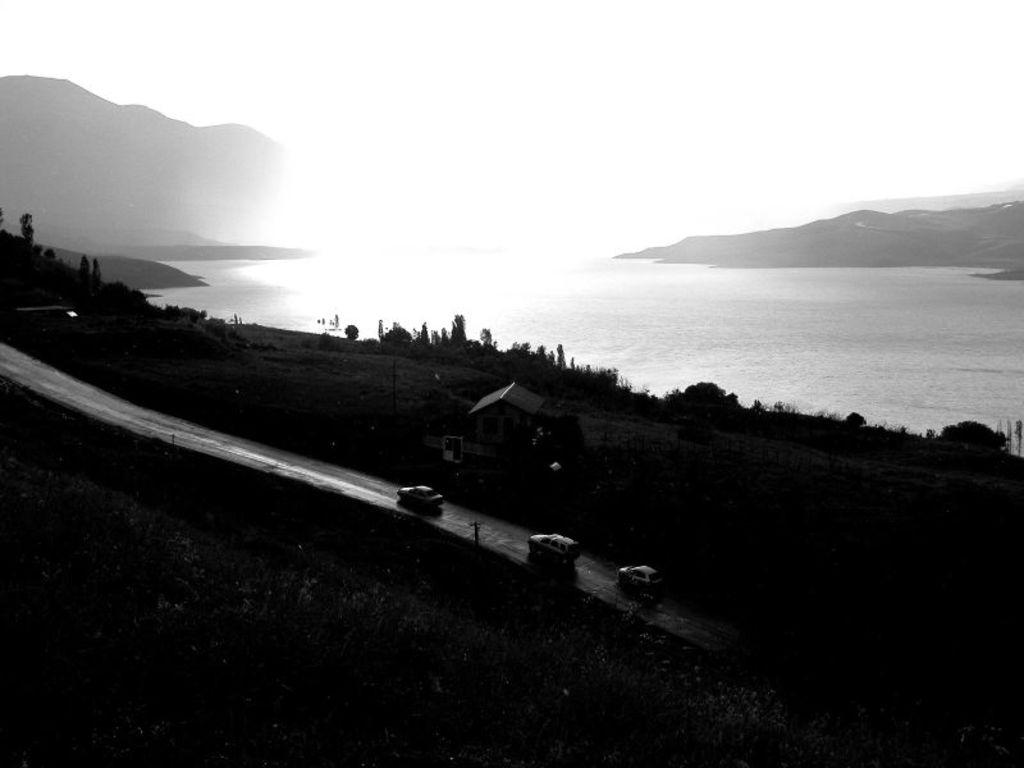What can be seen in the image? There are cars in the image. What type of vegetation or plants are visible at the bottom side of the image? There is greenery at the bottom side of the image. What natural feature is visible at the top side of the image? There is sea at the top side of the image. What is the topic of the discussion taking place in the image? There is no discussion taking place in the image, as it only shows cars, greenery, and sea. Can you see an orange fruit in the image? There is no orange fruit present in the image. 